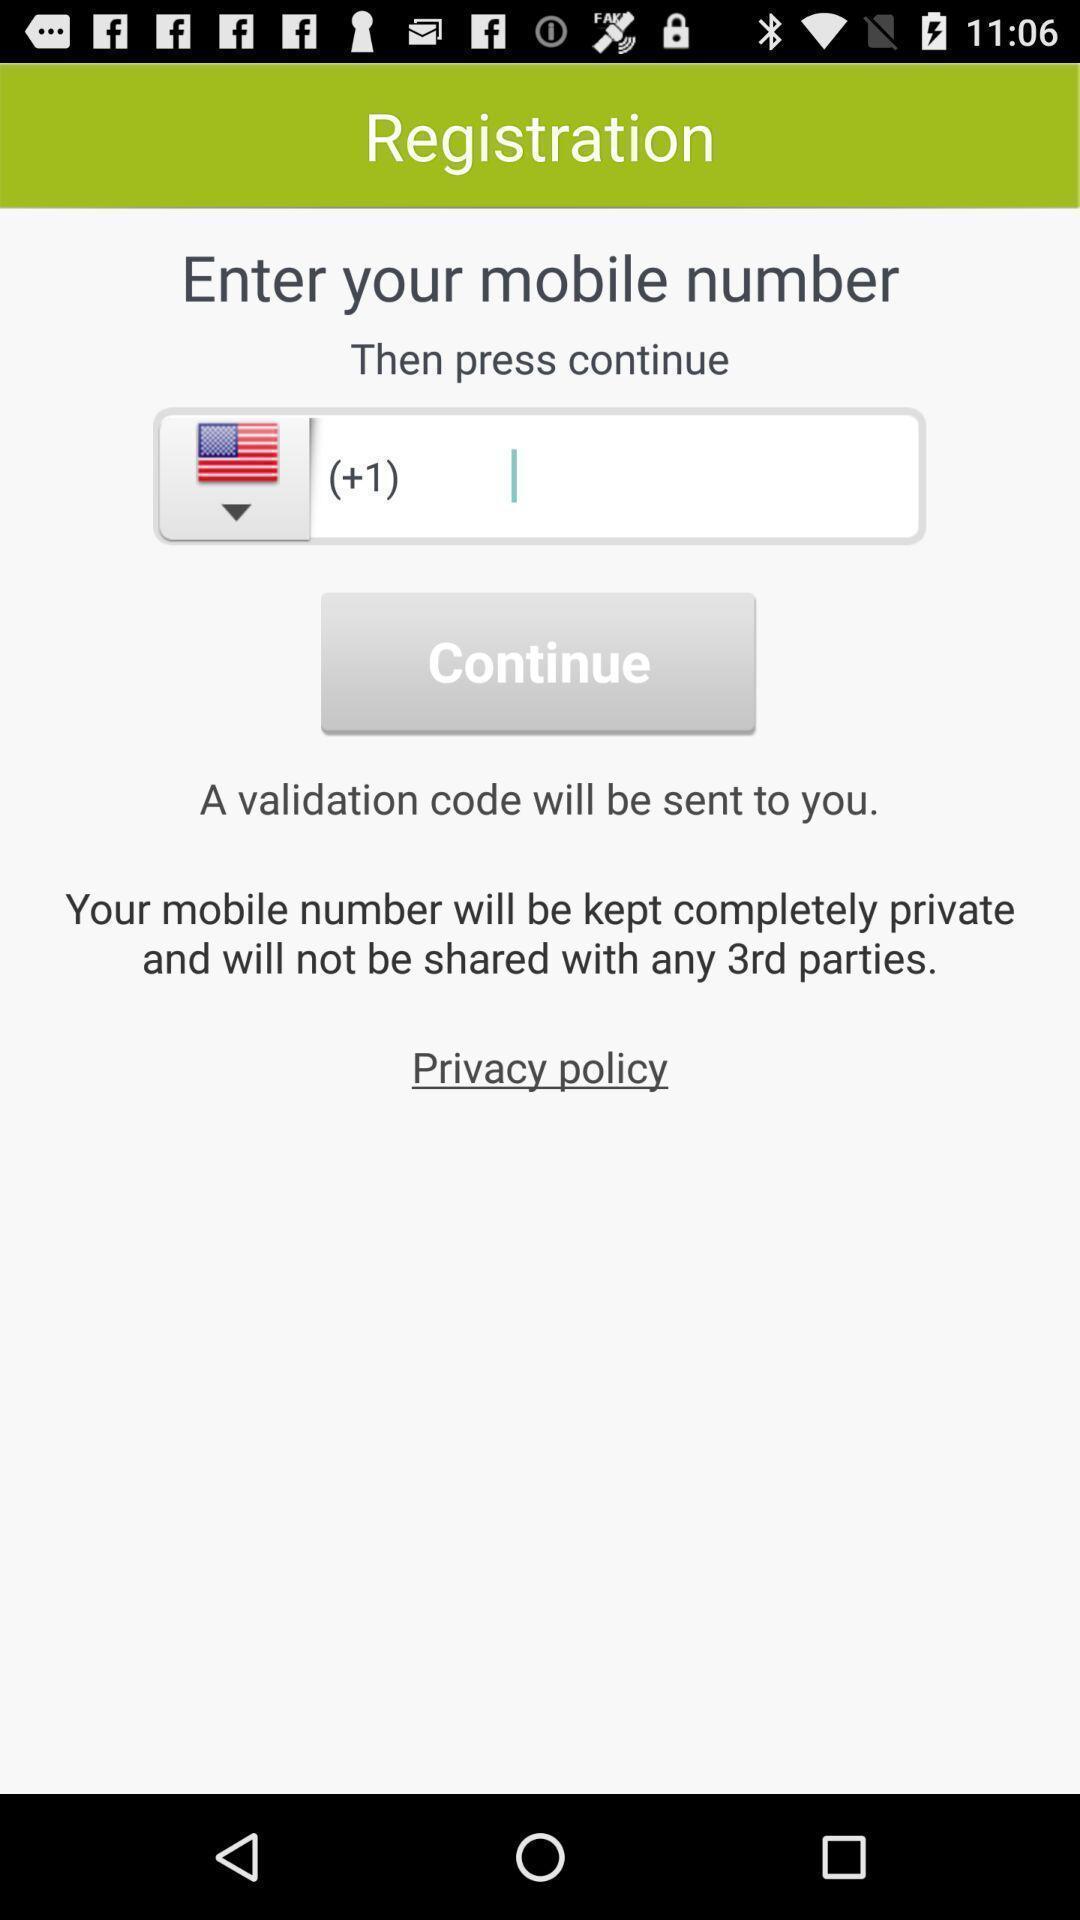Summarize the main components in this picture. Screen shows registration details. 